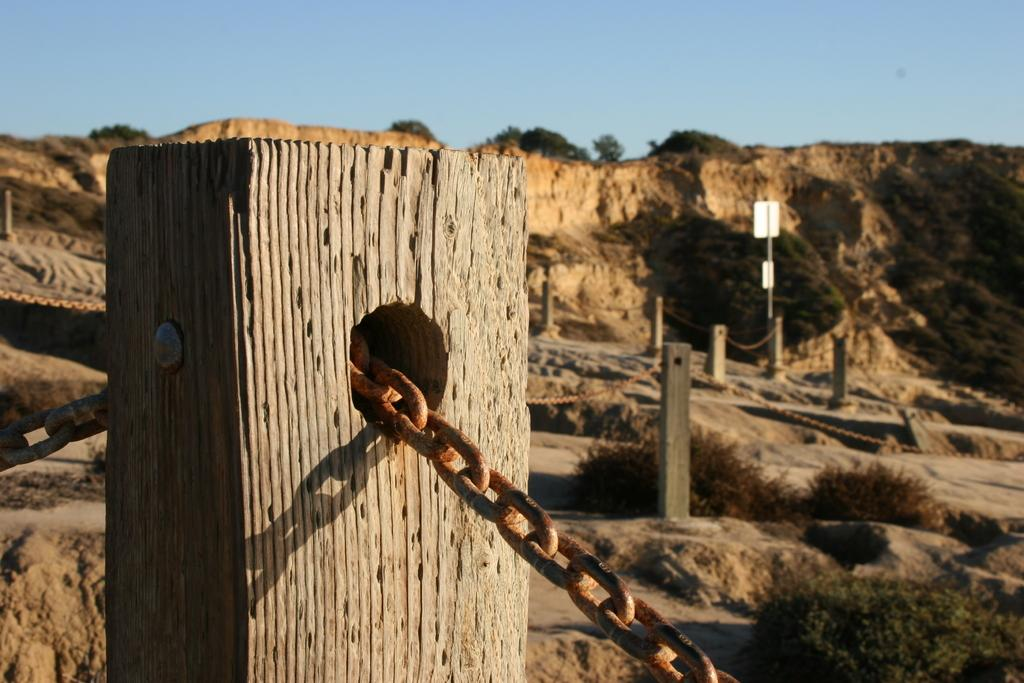What is located in the foreground of the image? In the foreground of the image, there is a fence, plants, a board, and trees. Can you describe the landscape in the foreground? The landscape in the foreground includes plants and trees. What is visible in the background of the image? In the background of the image, there are mountains and the sky. What time of day was the image taken? The image was taken during the day. What type of nut is being used to expand the fence in the image? There is no nut or expansion of the fence present in the image. What type of land can be seen in the image? The image does not specifically show any type of land; it features a fence, plants, a board, trees, mountains, and the sky. 